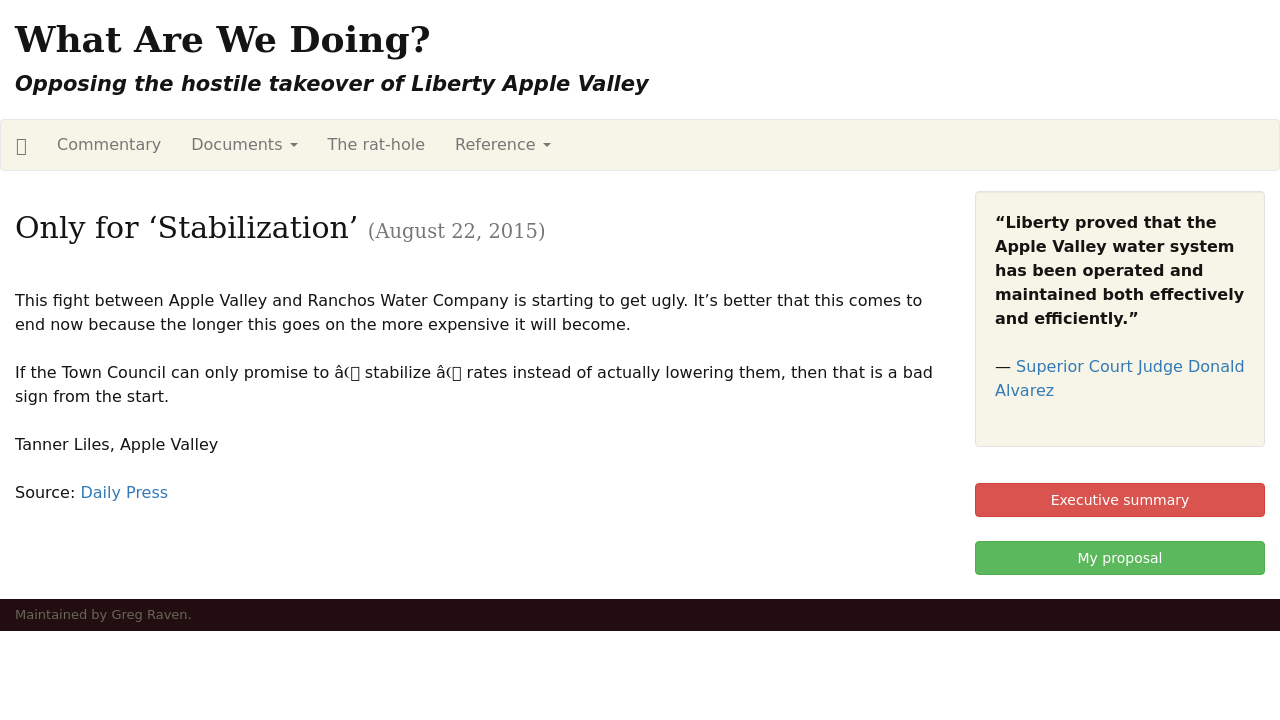How can I start building this website with HTML from the ground up? Starting to build a website with HTML from the ground up involves several steps. First, you should start by creating a basic HTML document structure. Here's a simple example:

<!DOCTYPE html>
<html>
<head>
    <title>Your Website Title</title>
</head>
<body>
    <h1>Welcome to My Website</h1>
    <p>This is a paragraph of text on my site.</p>
</body>
</html>

This code sets up a basic webpage with a title, a header, and a paragraph. You should expand this structure by adding more HTML elements such as headers, paragraphs, links, images, and lists according to the content needs of your website. Additionally, consider learning CSS to style your website and JavaScript to add interactivity. 